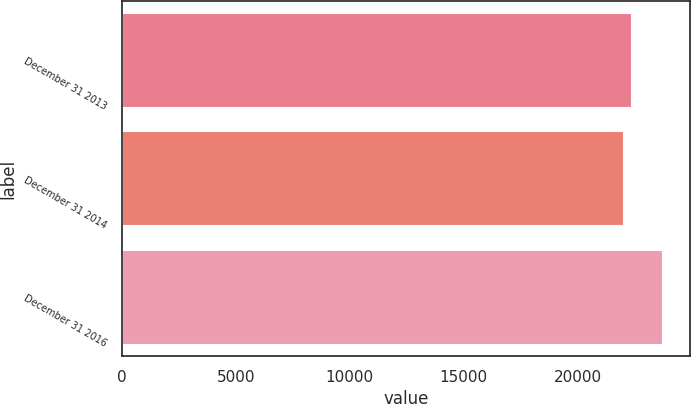<chart> <loc_0><loc_0><loc_500><loc_500><bar_chart><fcel>December 31 2013<fcel>December 31 2014<fcel>December 31 2016<nl><fcel>22392<fcel>22037<fcel>23725<nl></chart> 